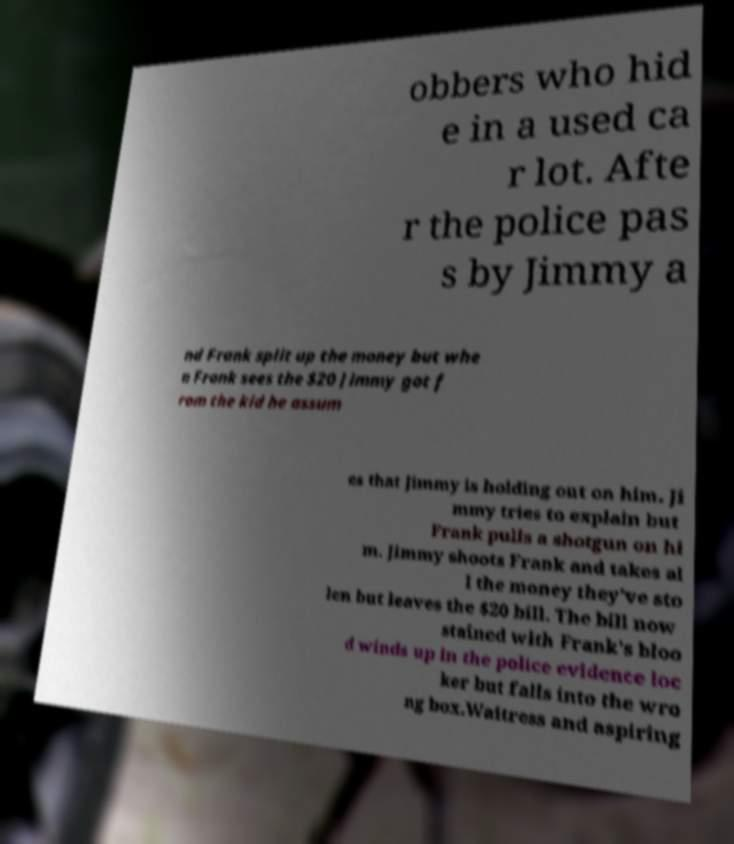Could you extract and type out the text from this image? obbers who hid e in a used ca r lot. Afte r the police pas s by Jimmy a nd Frank split up the money but whe n Frank sees the $20 Jimmy got f rom the kid he assum es that Jimmy is holding out on him. Ji mmy tries to explain but Frank pulls a shotgun on hi m. Jimmy shoots Frank and takes al l the money they've sto len but leaves the $20 bill. The bill now stained with Frank's bloo d winds up in the police evidence loc ker but falls into the wro ng box.Waitress and aspiring 